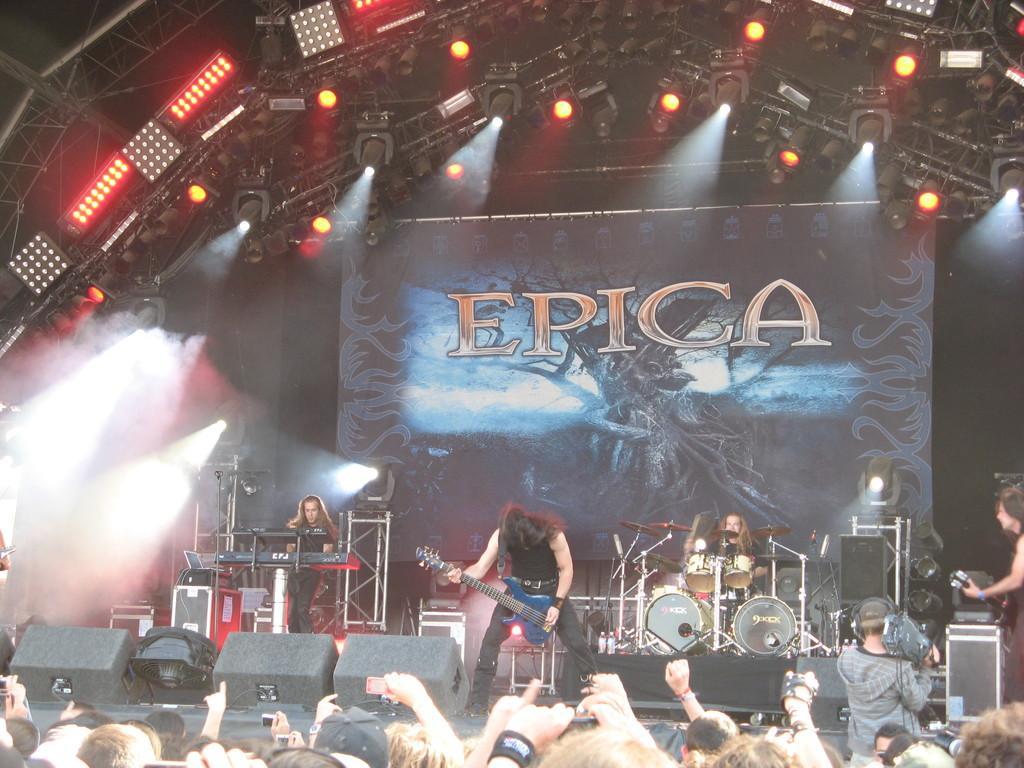Could you give a brief overview of what you see in this image? There is a music band on the stage who are playing a concert. There is a guy who is operating a piano. There is another one who is operating guitar. And in the right side there is a guy who is playing drums. And from the down audience are enjoying their concert. There are some lights and smoke in the background. 